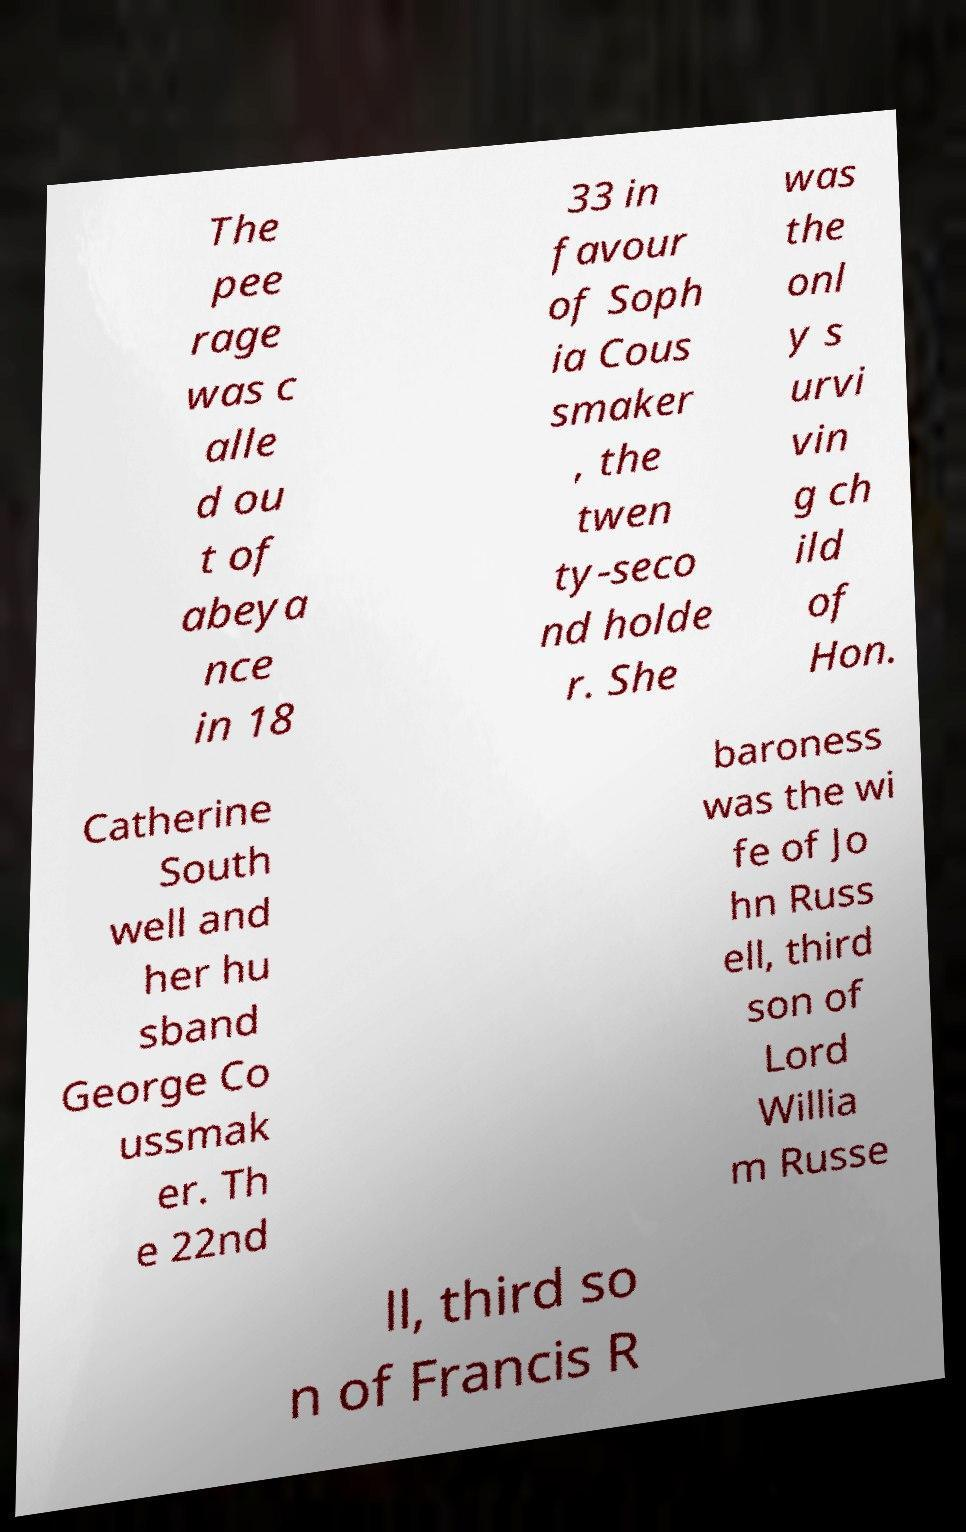Can you accurately transcribe the text from the provided image for me? The pee rage was c alle d ou t of abeya nce in 18 33 in favour of Soph ia Cous smaker , the twen ty-seco nd holde r. She was the onl y s urvi vin g ch ild of Hon. Catherine South well and her hu sband George Co ussmak er. Th e 22nd baroness was the wi fe of Jo hn Russ ell, third son of Lord Willia m Russe ll, third so n of Francis R 